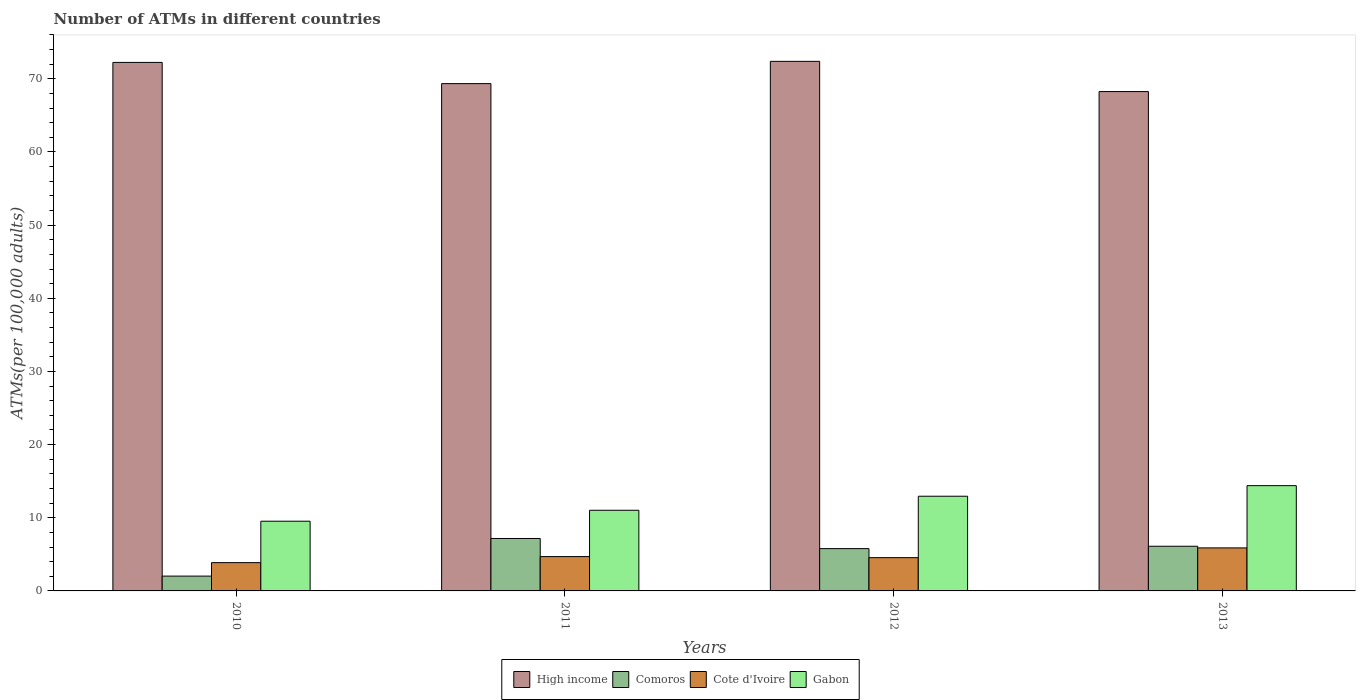How many different coloured bars are there?
Provide a succinct answer. 4. Are the number of bars on each tick of the X-axis equal?
Your response must be concise. Yes. How many bars are there on the 3rd tick from the left?
Provide a succinct answer. 4. What is the number of ATMs in Comoros in 2011?
Offer a terse response. 7.17. Across all years, what is the maximum number of ATMs in Comoros?
Make the answer very short. 7.17. Across all years, what is the minimum number of ATMs in Cote d'Ivoire?
Offer a very short reply. 3.87. In which year was the number of ATMs in Cote d'Ivoire maximum?
Provide a succinct answer. 2013. In which year was the number of ATMs in High income minimum?
Offer a very short reply. 2013. What is the total number of ATMs in Comoros in the graph?
Make the answer very short. 21.09. What is the difference between the number of ATMs in Cote d'Ivoire in 2011 and that in 2013?
Provide a succinct answer. -1.19. What is the difference between the number of ATMs in Cote d'Ivoire in 2011 and the number of ATMs in High income in 2013?
Give a very brief answer. -63.57. What is the average number of ATMs in Gabon per year?
Offer a terse response. 11.97. In the year 2010, what is the difference between the number of ATMs in Comoros and number of ATMs in High income?
Offer a very short reply. -70.22. In how many years, is the number of ATMs in Gabon greater than 50?
Ensure brevity in your answer.  0. What is the ratio of the number of ATMs in High income in 2010 to that in 2013?
Your answer should be very brief. 1.06. Is the number of ATMs in Cote d'Ivoire in 2011 less than that in 2013?
Your answer should be very brief. Yes. What is the difference between the highest and the second highest number of ATMs in Comoros?
Your answer should be very brief. 1.06. What is the difference between the highest and the lowest number of ATMs in Comoros?
Make the answer very short. 5.14. In how many years, is the number of ATMs in High income greater than the average number of ATMs in High income taken over all years?
Provide a succinct answer. 2. Is it the case that in every year, the sum of the number of ATMs in Gabon and number of ATMs in Comoros is greater than the sum of number of ATMs in Cote d'Ivoire and number of ATMs in High income?
Your response must be concise. No. What does the 3rd bar from the left in 2010 represents?
Provide a short and direct response. Cote d'Ivoire. What does the 2nd bar from the right in 2012 represents?
Make the answer very short. Cote d'Ivoire. Is it the case that in every year, the sum of the number of ATMs in Comoros and number of ATMs in High income is greater than the number of ATMs in Gabon?
Offer a very short reply. Yes. Are all the bars in the graph horizontal?
Offer a very short reply. No. What is the difference between two consecutive major ticks on the Y-axis?
Offer a terse response. 10. Are the values on the major ticks of Y-axis written in scientific E-notation?
Keep it short and to the point. No. Does the graph contain any zero values?
Provide a succinct answer. No. Where does the legend appear in the graph?
Your answer should be very brief. Bottom center. How many legend labels are there?
Keep it short and to the point. 4. What is the title of the graph?
Make the answer very short. Number of ATMs in different countries. What is the label or title of the X-axis?
Make the answer very short. Years. What is the label or title of the Y-axis?
Make the answer very short. ATMs(per 100,0 adults). What is the ATMs(per 100,000 adults) of High income in 2010?
Your answer should be very brief. 72.25. What is the ATMs(per 100,000 adults) of Comoros in 2010?
Keep it short and to the point. 2.03. What is the ATMs(per 100,000 adults) in Cote d'Ivoire in 2010?
Keep it short and to the point. 3.87. What is the ATMs(per 100,000 adults) in Gabon in 2010?
Offer a terse response. 9.53. What is the ATMs(per 100,000 adults) of High income in 2011?
Offer a terse response. 69.35. What is the ATMs(per 100,000 adults) of Comoros in 2011?
Make the answer very short. 7.17. What is the ATMs(per 100,000 adults) of Cote d'Ivoire in 2011?
Keep it short and to the point. 4.69. What is the ATMs(per 100,000 adults) in Gabon in 2011?
Make the answer very short. 11.03. What is the ATMs(per 100,000 adults) in High income in 2012?
Provide a succinct answer. 72.39. What is the ATMs(per 100,000 adults) in Comoros in 2012?
Offer a very short reply. 5.78. What is the ATMs(per 100,000 adults) of Cote d'Ivoire in 2012?
Your answer should be compact. 4.55. What is the ATMs(per 100,000 adults) of Gabon in 2012?
Provide a short and direct response. 12.95. What is the ATMs(per 100,000 adults) in High income in 2013?
Your answer should be very brief. 68.26. What is the ATMs(per 100,000 adults) of Comoros in 2013?
Keep it short and to the point. 6.11. What is the ATMs(per 100,000 adults) in Cote d'Ivoire in 2013?
Provide a succinct answer. 5.88. What is the ATMs(per 100,000 adults) in Gabon in 2013?
Provide a short and direct response. 14.39. Across all years, what is the maximum ATMs(per 100,000 adults) of High income?
Your answer should be very brief. 72.39. Across all years, what is the maximum ATMs(per 100,000 adults) in Comoros?
Ensure brevity in your answer.  7.17. Across all years, what is the maximum ATMs(per 100,000 adults) of Cote d'Ivoire?
Offer a very short reply. 5.88. Across all years, what is the maximum ATMs(per 100,000 adults) in Gabon?
Your answer should be very brief. 14.39. Across all years, what is the minimum ATMs(per 100,000 adults) in High income?
Your answer should be compact. 68.26. Across all years, what is the minimum ATMs(per 100,000 adults) in Comoros?
Your answer should be very brief. 2.03. Across all years, what is the minimum ATMs(per 100,000 adults) in Cote d'Ivoire?
Offer a very short reply. 3.87. Across all years, what is the minimum ATMs(per 100,000 adults) in Gabon?
Ensure brevity in your answer.  9.53. What is the total ATMs(per 100,000 adults) in High income in the graph?
Offer a very short reply. 282.24. What is the total ATMs(per 100,000 adults) of Comoros in the graph?
Your answer should be very brief. 21.09. What is the total ATMs(per 100,000 adults) in Cote d'Ivoire in the graph?
Give a very brief answer. 18.99. What is the total ATMs(per 100,000 adults) of Gabon in the graph?
Give a very brief answer. 47.89. What is the difference between the ATMs(per 100,000 adults) in High income in 2010 and that in 2011?
Give a very brief answer. 2.9. What is the difference between the ATMs(per 100,000 adults) of Comoros in 2010 and that in 2011?
Your response must be concise. -5.14. What is the difference between the ATMs(per 100,000 adults) in Cote d'Ivoire in 2010 and that in 2011?
Your answer should be compact. -0.83. What is the difference between the ATMs(per 100,000 adults) in Gabon in 2010 and that in 2011?
Keep it short and to the point. -1.5. What is the difference between the ATMs(per 100,000 adults) in High income in 2010 and that in 2012?
Make the answer very short. -0.14. What is the difference between the ATMs(per 100,000 adults) in Comoros in 2010 and that in 2012?
Offer a terse response. -3.76. What is the difference between the ATMs(per 100,000 adults) of Cote d'Ivoire in 2010 and that in 2012?
Provide a short and direct response. -0.68. What is the difference between the ATMs(per 100,000 adults) of Gabon in 2010 and that in 2012?
Your answer should be very brief. -3.42. What is the difference between the ATMs(per 100,000 adults) of High income in 2010 and that in 2013?
Provide a short and direct response. 3.99. What is the difference between the ATMs(per 100,000 adults) in Comoros in 2010 and that in 2013?
Keep it short and to the point. -4.08. What is the difference between the ATMs(per 100,000 adults) in Cote d'Ivoire in 2010 and that in 2013?
Ensure brevity in your answer.  -2.01. What is the difference between the ATMs(per 100,000 adults) of Gabon in 2010 and that in 2013?
Your answer should be very brief. -4.86. What is the difference between the ATMs(per 100,000 adults) of High income in 2011 and that in 2012?
Ensure brevity in your answer.  -3.04. What is the difference between the ATMs(per 100,000 adults) of Comoros in 2011 and that in 2012?
Make the answer very short. 1.38. What is the difference between the ATMs(per 100,000 adults) of Cote d'Ivoire in 2011 and that in 2012?
Offer a very short reply. 0.15. What is the difference between the ATMs(per 100,000 adults) in Gabon in 2011 and that in 2012?
Give a very brief answer. -1.92. What is the difference between the ATMs(per 100,000 adults) in High income in 2011 and that in 2013?
Offer a very short reply. 1.09. What is the difference between the ATMs(per 100,000 adults) in Comoros in 2011 and that in 2013?
Make the answer very short. 1.06. What is the difference between the ATMs(per 100,000 adults) of Cote d'Ivoire in 2011 and that in 2013?
Offer a terse response. -1.19. What is the difference between the ATMs(per 100,000 adults) in Gabon in 2011 and that in 2013?
Your answer should be compact. -3.37. What is the difference between the ATMs(per 100,000 adults) of High income in 2012 and that in 2013?
Your response must be concise. 4.13. What is the difference between the ATMs(per 100,000 adults) in Comoros in 2012 and that in 2013?
Give a very brief answer. -0.32. What is the difference between the ATMs(per 100,000 adults) in Cote d'Ivoire in 2012 and that in 2013?
Keep it short and to the point. -1.33. What is the difference between the ATMs(per 100,000 adults) in Gabon in 2012 and that in 2013?
Offer a very short reply. -1.45. What is the difference between the ATMs(per 100,000 adults) of High income in 2010 and the ATMs(per 100,000 adults) of Comoros in 2011?
Provide a short and direct response. 65.08. What is the difference between the ATMs(per 100,000 adults) in High income in 2010 and the ATMs(per 100,000 adults) in Cote d'Ivoire in 2011?
Your answer should be compact. 67.55. What is the difference between the ATMs(per 100,000 adults) of High income in 2010 and the ATMs(per 100,000 adults) of Gabon in 2011?
Your answer should be compact. 61.22. What is the difference between the ATMs(per 100,000 adults) of Comoros in 2010 and the ATMs(per 100,000 adults) of Cote d'Ivoire in 2011?
Provide a succinct answer. -2.67. What is the difference between the ATMs(per 100,000 adults) in Comoros in 2010 and the ATMs(per 100,000 adults) in Gabon in 2011?
Give a very brief answer. -9. What is the difference between the ATMs(per 100,000 adults) of Cote d'Ivoire in 2010 and the ATMs(per 100,000 adults) of Gabon in 2011?
Your answer should be very brief. -7.16. What is the difference between the ATMs(per 100,000 adults) of High income in 2010 and the ATMs(per 100,000 adults) of Comoros in 2012?
Offer a terse response. 66.46. What is the difference between the ATMs(per 100,000 adults) of High income in 2010 and the ATMs(per 100,000 adults) of Cote d'Ivoire in 2012?
Give a very brief answer. 67.7. What is the difference between the ATMs(per 100,000 adults) in High income in 2010 and the ATMs(per 100,000 adults) in Gabon in 2012?
Your answer should be compact. 59.3. What is the difference between the ATMs(per 100,000 adults) of Comoros in 2010 and the ATMs(per 100,000 adults) of Cote d'Ivoire in 2012?
Keep it short and to the point. -2.52. What is the difference between the ATMs(per 100,000 adults) in Comoros in 2010 and the ATMs(per 100,000 adults) in Gabon in 2012?
Provide a succinct answer. -10.92. What is the difference between the ATMs(per 100,000 adults) of Cote d'Ivoire in 2010 and the ATMs(per 100,000 adults) of Gabon in 2012?
Keep it short and to the point. -9.08. What is the difference between the ATMs(per 100,000 adults) of High income in 2010 and the ATMs(per 100,000 adults) of Comoros in 2013?
Your answer should be compact. 66.14. What is the difference between the ATMs(per 100,000 adults) of High income in 2010 and the ATMs(per 100,000 adults) of Cote d'Ivoire in 2013?
Your answer should be compact. 66.36. What is the difference between the ATMs(per 100,000 adults) of High income in 2010 and the ATMs(per 100,000 adults) of Gabon in 2013?
Your response must be concise. 57.86. What is the difference between the ATMs(per 100,000 adults) in Comoros in 2010 and the ATMs(per 100,000 adults) in Cote d'Ivoire in 2013?
Your answer should be very brief. -3.86. What is the difference between the ATMs(per 100,000 adults) in Comoros in 2010 and the ATMs(per 100,000 adults) in Gabon in 2013?
Give a very brief answer. -12.36. What is the difference between the ATMs(per 100,000 adults) of Cote d'Ivoire in 2010 and the ATMs(per 100,000 adults) of Gabon in 2013?
Provide a short and direct response. -10.52. What is the difference between the ATMs(per 100,000 adults) in High income in 2011 and the ATMs(per 100,000 adults) in Comoros in 2012?
Provide a succinct answer. 63.56. What is the difference between the ATMs(per 100,000 adults) in High income in 2011 and the ATMs(per 100,000 adults) in Cote d'Ivoire in 2012?
Give a very brief answer. 64.8. What is the difference between the ATMs(per 100,000 adults) of High income in 2011 and the ATMs(per 100,000 adults) of Gabon in 2012?
Offer a very short reply. 56.4. What is the difference between the ATMs(per 100,000 adults) of Comoros in 2011 and the ATMs(per 100,000 adults) of Cote d'Ivoire in 2012?
Make the answer very short. 2.62. What is the difference between the ATMs(per 100,000 adults) of Comoros in 2011 and the ATMs(per 100,000 adults) of Gabon in 2012?
Your answer should be compact. -5.78. What is the difference between the ATMs(per 100,000 adults) in Cote d'Ivoire in 2011 and the ATMs(per 100,000 adults) in Gabon in 2012?
Make the answer very short. -8.25. What is the difference between the ATMs(per 100,000 adults) of High income in 2011 and the ATMs(per 100,000 adults) of Comoros in 2013?
Give a very brief answer. 63.24. What is the difference between the ATMs(per 100,000 adults) in High income in 2011 and the ATMs(per 100,000 adults) in Cote d'Ivoire in 2013?
Offer a very short reply. 63.47. What is the difference between the ATMs(per 100,000 adults) in High income in 2011 and the ATMs(per 100,000 adults) in Gabon in 2013?
Your answer should be compact. 54.96. What is the difference between the ATMs(per 100,000 adults) in Comoros in 2011 and the ATMs(per 100,000 adults) in Cote d'Ivoire in 2013?
Provide a succinct answer. 1.29. What is the difference between the ATMs(per 100,000 adults) in Comoros in 2011 and the ATMs(per 100,000 adults) in Gabon in 2013?
Your answer should be very brief. -7.22. What is the difference between the ATMs(per 100,000 adults) in Cote d'Ivoire in 2011 and the ATMs(per 100,000 adults) in Gabon in 2013?
Offer a very short reply. -9.7. What is the difference between the ATMs(per 100,000 adults) in High income in 2012 and the ATMs(per 100,000 adults) in Comoros in 2013?
Your answer should be very brief. 66.28. What is the difference between the ATMs(per 100,000 adults) in High income in 2012 and the ATMs(per 100,000 adults) in Cote d'Ivoire in 2013?
Keep it short and to the point. 66.51. What is the difference between the ATMs(per 100,000 adults) of High income in 2012 and the ATMs(per 100,000 adults) of Gabon in 2013?
Keep it short and to the point. 58. What is the difference between the ATMs(per 100,000 adults) in Comoros in 2012 and the ATMs(per 100,000 adults) in Cote d'Ivoire in 2013?
Provide a short and direct response. -0.1. What is the difference between the ATMs(per 100,000 adults) in Comoros in 2012 and the ATMs(per 100,000 adults) in Gabon in 2013?
Make the answer very short. -8.61. What is the difference between the ATMs(per 100,000 adults) in Cote d'Ivoire in 2012 and the ATMs(per 100,000 adults) in Gabon in 2013?
Ensure brevity in your answer.  -9.84. What is the average ATMs(per 100,000 adults) of High income per year?
Your response must be concise. 70.56. What is the average ATMs(per 100,000 adults) of Comoros per year?
Provide a short and direct response. 5.27. What is the average ATMs(per 100,000 adults) in Cote d'Ivoire per year?
Offer a very short reply. 4.75. What is the average ATMs(per 100,000 adults) of Gabon per year?
Your response must be concise. 11.97. In the year 2010, what is the difference between the ATMs(per 100,000 adults) in High income and ATMs(per 100,000 adults) in Comoros?
Your response must be concise. 70.22. In the year 2010, what is the difference between the ATMs(per 100,000 adults) in High income and ATMs(per 100,000 adults) in Cote d'Ivoire?
Offer a terse response. 68.38. In the year 2010, what is the difference between the ATMs(per 100,000 adults) of High income and ATMs(per 100,000 adults) of Gabon?
Your answer should be very brief. 62.72. In the year 2010, what is the difference between the ATMs(per 100,000 adults) of Comoros and ATMs(per 100,000 adults) of Cote d'Ivoire?
Offer a very short reply. -1.84. In the year 2010, what is the difference between the ATMs(per 100,000 adults) of Comoros and ATMs(per 100,000 adults) of Gabon?
Your response must be concise. -7.5. In the year 2010, what is the difference between the ATMs(per 100,000 adults) in Cote d'Ivoire and ATMs(per 100,000 adults) in Gabon?
Make the answer very short. -5.66. In the year 2011, what is the difference between the ATMs(per 100,000 adults) in High income and ATMs(per 100,000 adults) in Comoros?
Offer a very short reply. 62.18. In the year 2011, what is the difference between the ATMs(per 100,000 adults) in High income and ATMs(per 100,000 adults) in Cote d'Ivoire?
Your answer should be very brief. 64.65. In the year 2011, what is the difference between the ATMs(per 100,000 adults) of High income and ATMs(per 100,000 adults) of Gabon?
Keep it short and to the point. 58.32. In the year 2011, what is the difference between the ATMs(per 100,000 adults) of Comoros and ATMs(per 100,000 adults) of Cote d'Ivoire?
Provide a succinct answer. 2.47. In the year 2011, what is the difference between the ATMs(per 100,000 adults) in Comoros and ATMs(per 100,000 adults) in Gabon?
Make the answer very short. -3.86. In the year 2011, what is the difference between the ATMs(per 100,000 adults) in Cote d'Ivoire and ATMs(per 100,000 adults) in Gabon?
Your response must be concise. -6.33. In the year 2012, what is the difference between the ATMs(per 100,000 adults) of High income and ATMs(per 100,000 adults) of Comoros?
Your answer should be very brief. 66.61. In the year 2012, what is the difference between the ATMs(per 100,000 adults) in High income and ATMs(per 100,000 adults) in Cote d'Ivoire?
Your response must be concise. 67.84. In the year 2012, what is the difference between the ATMs(per 100,000 adults) in High income and ATMs(per 100,000 adults) in Gabon?
Offer a very short reply. 59.45. In the year 2012, what is the difference between the ATMs(per 100,000 adults) of Comoros and ATMs(per 100,000 adults) of Cote d'Ivoire?
Give a very brief answer. 1.24. In the year 2012, what is the difference between the ATMs(per 100,000 adults) of Comoros and ATMs(per 100,000 adults) of Gabon?
Offer a terse response. -7.16. In the year 2012, what is the difference between the ATMs(per 100,000 adults) in Cote d'Ivoire and ATMs(per 100,000 adults) in Gabon?
Your response must be concise. -8.4. In the year 2013, what is the difference between the ATMs(per 100,000 adults) in High income and ATMs(per 100,000 adults) in Comoros?
Offer a terse response. 62.15. In the year 2013, what is the difference between the ATMs(per 100,000 adults) in High income and ATMs(per 100,000 adults) in Cote d'Ivoire?
Your answer should be compact. 62.38. In the year 2013, what is the difference between the ATMs(per 100,000 adults) of High income and ATMs(per 100,000 adults) of Gabon?
Provide a short and direct response. 53.87. In the year 2013, what is the difference between the ATMs(per 100,000 adults) in Comoros and ATMs(per 100,000 adults) in Cote d'Ivoire?
Give a very brief answer. 0.23. In the year 2013, what is the difference between the ATMs(per 100,000 adults) of Comoros and ATMs(per 100,000 adults) of Gabon?
Your answer should be very brief. -8.28. In the year 2013, what is the difference between the ATMs(per 100,000 adults) in Cote d'Ivoire and ATMs(per 100,000 adults) in Gabon?
Your answer should be very brief. -8.51. What is the ratio of the ATMs(per 100,000 adults) of High income in 2010 to that in 2011?
Give a very brief answer. 1.04. What is the ratio of the ATMs(per 100,000 adults) in Comoros in 2010 to that in 2011?
Give a very brief answer. 0.28. What is the ratio of the ATMs(per 100,000 adults) in Cote d'Ivoire in 2010 to that in 2011?
Provide a succinct answer. 0.82. What is the ratio of the ATMs(per 100,000 adults) of Gabon in 2010 to that in 2011?
Your answer should be compact. 0.86. What is the ratio of the ATMs(per 100,000 adults) of High income in 2010 to that in 2012?
Ensure brevity in your answer.  1. What is the ratio of the ATMs(per 100,000 adults) of Comoros in 2010 to that in 2012?
Make the answer very short. 0.35. What is the ratio of the ATMs(per 100,000 adults) in Cote d'Ivoire in 2010 to that in 2012?
Offer a very short reply. 0.85. What is the ratio of the ATMs(per 100,000 adults) of Gabon in 2010 to that in 2012?
Your response must be concise. 0.74. What is the ratio of the ATMs(per 100,000 adults) of High income in 2010 to that in 2013?
Your response must be concise. 1.06. What is the ratio of the ATMs(per 100,000 adults) of Comoros in 2010 to that in 2013?
Make the answer very short. 0.33. What is the ratio of the ATMs(per 100,000 adults) in Cote d'Ivoire in 2010 to that in 2013?
Give a very brief answer. 0.66. What is the ratio of the ATMs(per 100,000 adults) in Gabon in 2010 to that in 2013?
Provide a succinct answer. 0.66. What is the ratio of the ATMs(per 100,000 adults) in High income in 2011 to that in 2012?
Give a very brief answer. 0.96. What is the ratio of the ATMs(per 100,000 adults) in Comoros in 2011 to that in 2012?
Offer a terse response. 1.24. What is the ratio of the ATMs(per 100,000 adults) in Cote d'Ivoire in 2011 to that in 2012?
Provide a short and direct response. 1.03. What is the ratio of the ATMs(per 100,000 adults) of Gabon in 2011 to that in 2012?
Keep it short and to the point. 0.85. What is the ratio of the ATMs(per 100,000 adults) of High income in 2011 to that in 2013?
Give a very brief answer. 1.02. What is the ratio of the ATMs(per 100,000 adults) of Comoros in 2011 to that in 2013?
Your answer should be very brief. 1.17. What is the ratio of the ATMs(per 100,000 adults) in Cote d'Ivoire in 2011 to that in 2013?
Give a very brief answer. 0.8. What is the ratio of the ATMs(per 100,000 adults) in Gabon in 2011 to that in 2013?
Give a very brief answer. 0.77. What is the ratio of the ATMs(per 100,000 adults) in High income in 2012 to that in 2013?
Your answer should be compact. 1.06. What is the ratio of the ATMs(per 100,000 adults) of Comoros in 2012 to that in 2013?
Your answer should be very brief. 0.95. What is the ratio of the ATMs(per 100,000 adults) in Cote d'Ivoire in 2012 to that in 2013?
Give a very brief answer. 0.77. What is the ratio of the ATMs(per 100,000 adults) in Gabon in 2012 to that in 2013?
Provide a short and direct response. 0.9. What is the difference between the highest and the second highest ATMs(per 100,000 adults) in High income?
Offer a terse response. 0.14. What is the difference between the highest and the second highest ATMs(per 100,000 adults) of Comoros?
Make the answer very short. 1.06. What is the difference between the highest and the second highest ATMs(per 100,000 adults) of Cote d'Ivoire?
Give a very brief answer. 1.19. What is the difference between the highest and the second highest ATMs(per 100,000 adults) of Gabon?
Make the answer very short. 1.45. What is the difference between the highest and the lowest ATMs(per 100,000 adults) of High income?
Give a very brief answer. 4.13. What is the difference between the highest and the lowest ATMs(per 100,000 adults) in Comoros?
Offer a very short reply. 5.14. What is the difference between the highest and the lowest ATMs(per 100,000 adults) of Cote d'Ivoire?
Ensure brevity in your answer.  2.01. What is the difference between the highest and the lowest ATMs(per 100,000 adults) in Gabon?
Keep it short and to the point. 4.86. 